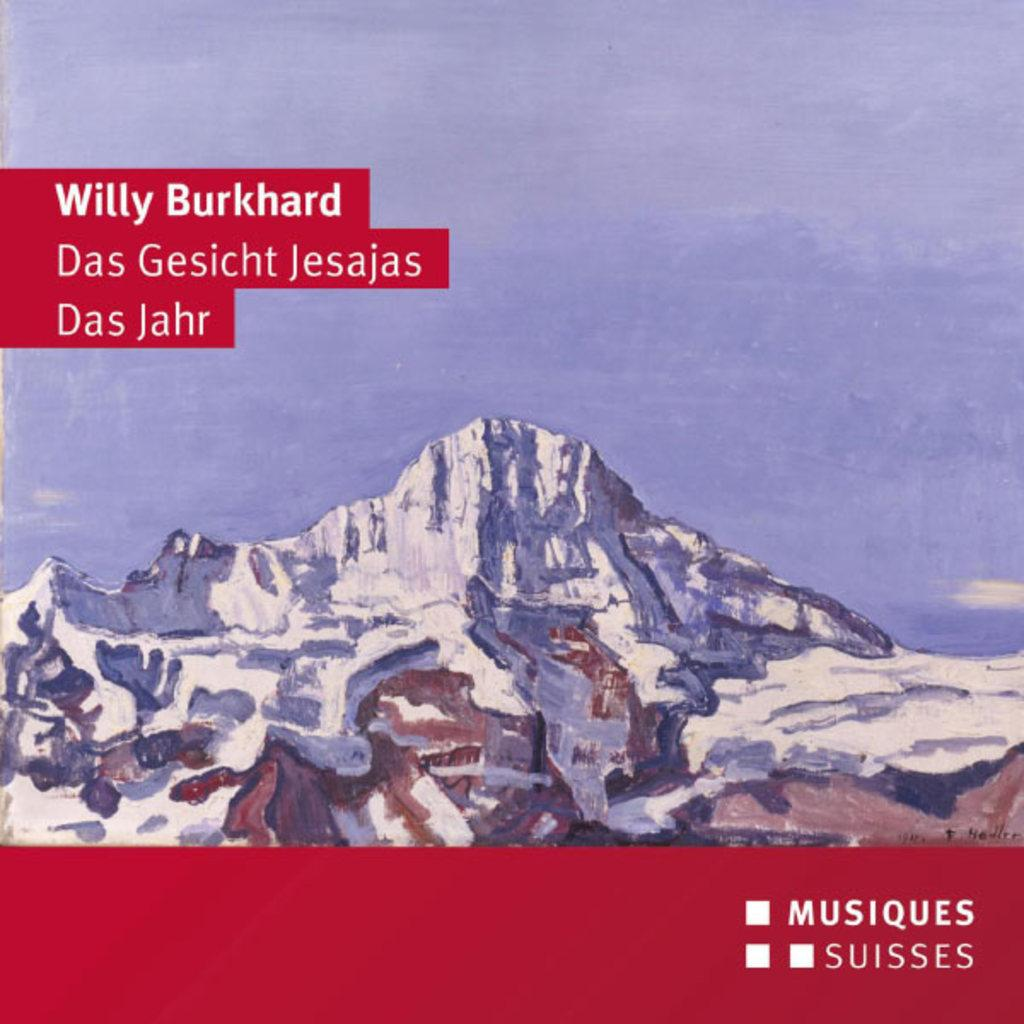What can be found in the image that contains written text? There is text written in the image. What type of scenery is depicted in the background of the image? There is a drawing of mountains in the background of the image. What type of house is visible in the image? There is no house present in the image; it only contains text and a drawing of mountains. What meal is being prepared in the image? There is no meal preparation depicted in the image; it only contains text and a drawing of mountains. 